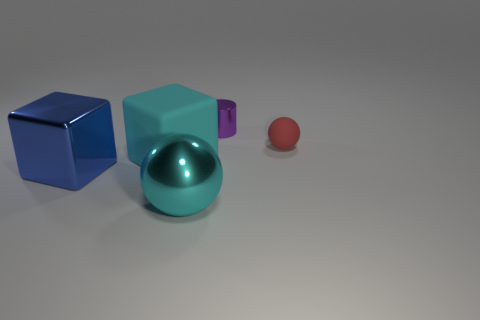Subtract 2 cubes. How many cubes are left? 0 Subtract all blocks. How many objects are left? 3 Subtract all brown cylinders. How many cyan blocks are left? 1 Add 2 large matte blocks. How many objects exist? 7 Subtract all large yellow shiny spheres. Subtract all big cyan balls. How many objects are left? 4 Add 1 small purple things. How many small purple things are left? 2 Add 2 tiny cyan matte balls. How many tiny cyan matte balls exist? 2 Subtract 1 red spheres. How many objects are left? 4 Subtract all blue blocks. Subtract all brown spheres. How many blocks are left? 1 